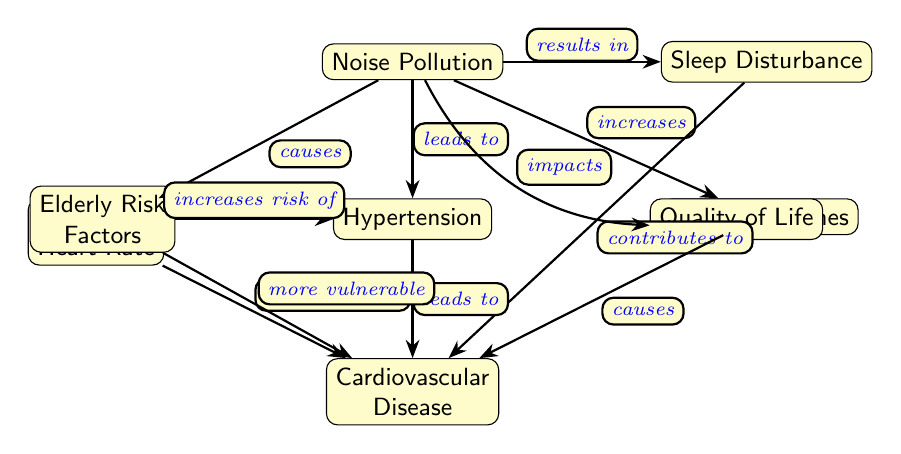What is the main factor depicted in the diagram that impacts cardiovascular health? The main factor is "Noise Pollution," as it is the starting node from which various effects radiate outwards.
Answer: Noise Pollution How many outcomes are directly linked to Noise Pollution? There are four outcomes directly linked to Noise Pollution as indicated by the four edges leading from it to other nodes ("Increased Heart Rate," "Hypertension," "Stress Hormones," and "Sleep Disturbance").
Answer: 4 What condition does Sleep Disturbance contribute to? Sleep Disturbance contributes to "Cardiovascular Disease," which demonstrates a direct causal relationship as shown by the edge connecting the two nodes.
Answer: Cardiovascular Disease Which risk factor increases the likelihood of Hypertension? "Elderly Risk Factors" are indicated in the diagram as increasing the risk of developing Hypertension. This is shown by the edge that connects the "Elderly Risk Factors" node to the "Hypertension" node.
Answer: Elderly Risk Factors What is the relationship between Stress Hormones and Cardiovascular Disease? The relationship is that Stress Hormones "cause" Cardiovascular Disease, shown by the direct edge from "Stress Hormones" to "Cardiovascular Disease."
Answer: causes How does Noise Pollution impact Quality of Life according to the diagram? Noise Pollution "impacts" Quality of Life, which is represented by the edge that connects the two nodes. The phrasing indicates a direct effect but does not suggest a quantifiable measure.
Answer: impacts What are the consequences of Hypertension as illustrated in the diagram? The consequences of Hypertension are "Cardiovascular Disease," indicated by the direct edge that shows Hypertension leads to this serious health condition.
Answer: Cardiovascular Disease What contributes both to Cardiovascular Disease and Sleep Disturbance? "Increased Heart Rate" contributes to both Cardiovascular Disease and indirectly to Sleep Disturbance, as shown through the connections of this node.
Answer: Increased Heart Rate What is the direction of the relationship between Increased Heart Rate and Cardiovascular Disease? The direction of relationship is that Increased Heart Rate "contributes to" Cardiovascular Disease, as shown by the edge connecting them.
Answer: contributes to 